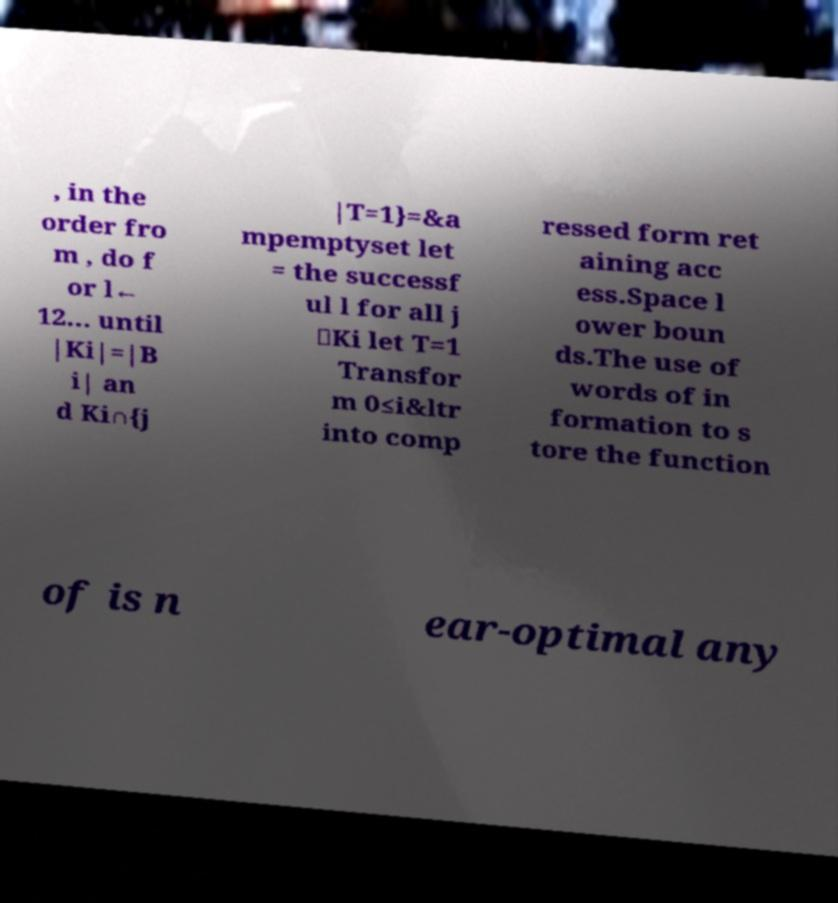Could you extract and type out the text from this image? , in the order fro m , do f or l← 12... until |Ki|=|B i| an d Ki∩{j |T=1}=&a mpemptyset let = the successf ul l for all j ∈Ki let T=1 Transfor m 0≤i&ltr into comp ressed form ret aining acc ess.Space l ower boun ds.The use of words of in formation to s tore the function of is n ear-optimal any 